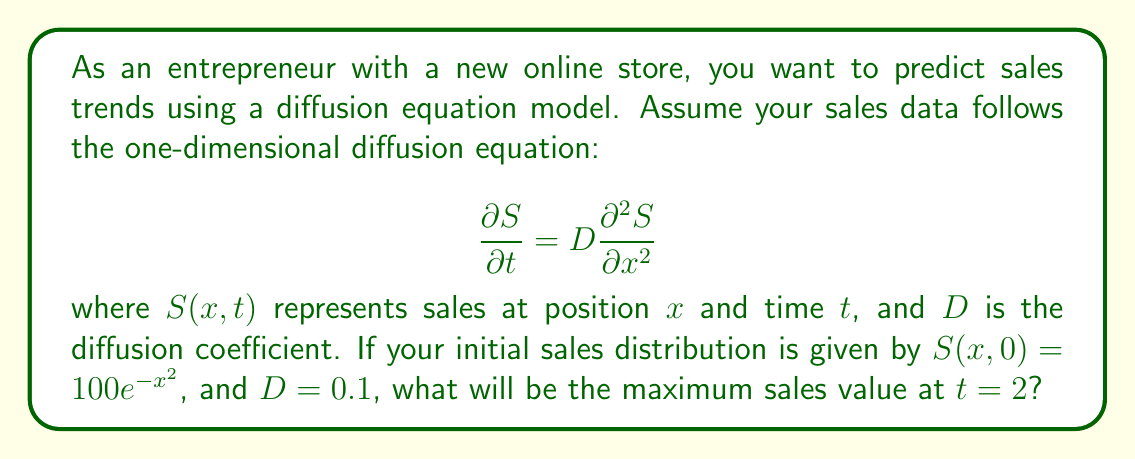Can you answer this question? To solve this problem, we need to use the fundamental solution of the diffusion equation, also known as the heat kernel. The solution for the given initial condition is:

$$S(x,t) = \frac{1}{\sqrt{1 + 4Dt}} \cdot 100e^{-\frac{x^2}{1 + 4Dt}}$$

To find the maximum sales value at $t = 2$, we need to:

1. Substitute $t = 2$ and $D = 0.1$ into the equation:

$$S(x,2) = \frac{1}{\sqrt{1 + 4(0.1)(2)}} \cdot 100e^{-\frac{x^2}{1 + 4(0.1)(2)}}$$

$$S(x,2) = \frac{100}{\sqrt{1.8}} \cdot e^{-\frac{x^2}{1.8}}$$

2. The maximum value will occur at $x = 0$ (center of the distribution), so:

$$S_{max} = S(0,2) = \frac{100}{\sqrt{1.8}} \cdot e^0 = \frac{100}{\sqrt{1.8}}$$

3. Calculate the final value:

$$S_{max} = \frac{100}{\sqrt{1.8}} \approx 74.54$$
Answer: The maximum sales value at $t = 2$ will be approximately 74.54 units. 